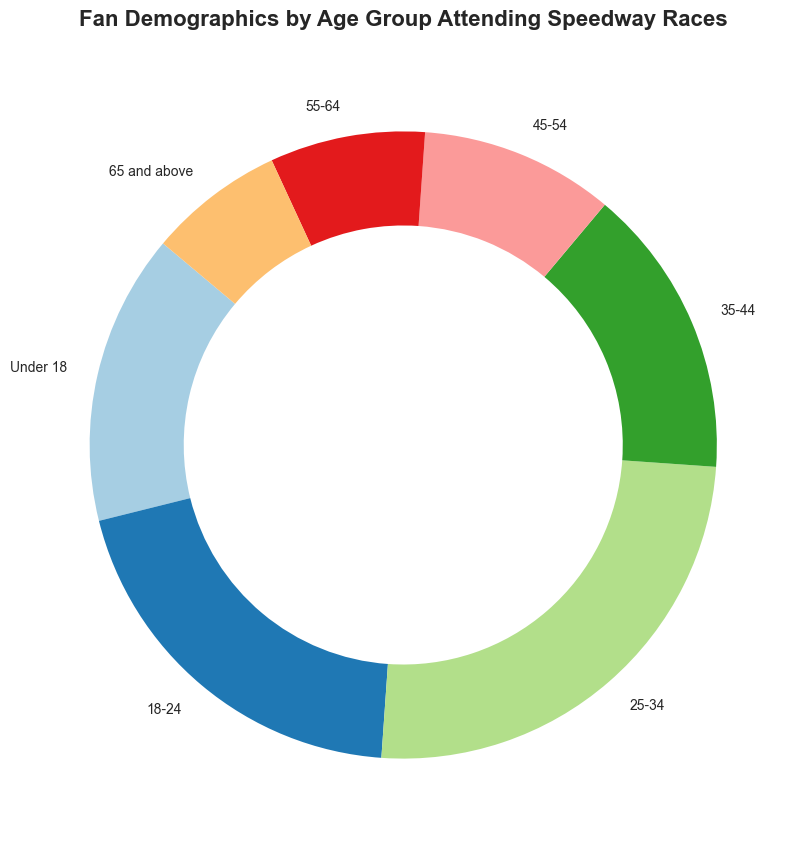What's the age group with the highest percentage of fans attending speedway races? The slice with the largest sector in the pie chart represents the age group with the highest percentage. Here, the 25-34 age group covers the largest area.
Answer: 25-34 Which age groups have an equal percentage of fans attending speedway races? Look for slices with the same size and corresponding labels. The Under 18 and 35-44 age groups each have a 15% share of the pie chart.
Answer: Under 18, 35-44 What is the combined percentage of fans aged 18-44 attending speedway races? Sum the percentages for the 18-24, 25-34, and 35-44 age groups. This adds up to 20 + 25 + 15 = 60%.
Answer: 60% How much smaller is the percentage of fans aged 65 and above compared to fans aged 25-34? Subtract the percentage of fans aged 65 and above from the percentage of fans aged 25-34: 25 - 7 = 18%.
Answer: 18% What is the 2nd most represented age group among the speedway fans? Identify the second-largest sector in the pie chart. The 18-24 age group appears second-largest with 20%.
Answer: 18-24 Is the percentage of fans aged 45-54 greater than 10%? Observe the slice labeled 45-54; it precisely covers 10% of the pie.
Answer: No Which age group has the smallest percentage of speedway fans? Identify the tiniest sector in the pie chart. The 65 and above group is smallest with 7%.
Answer: 65 and above What is the difference in percentage between the age groups 18-24 and 55-64? Subtract the percentage of the 55-64 group (8%) from the 18-24 group (20%): 20 - 8 = 12%.
Answer: 12% Which age group takes up about a quarter of the pie? Look for the slice that represents roughly 25% of the pie. The 25-34 age group meets this criterion.
Answer: 25-34 